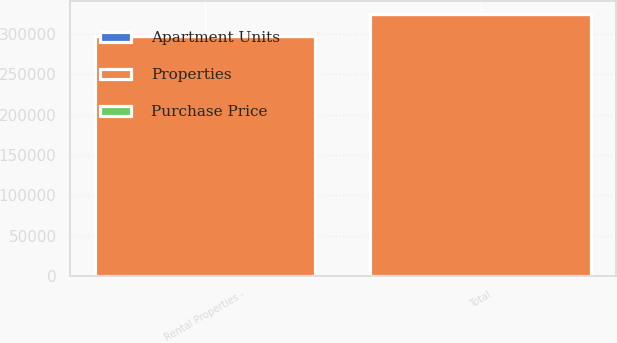<chart> <loc_0><loc_0><loc_500><loc_500><stacked_bar_chart><ecel><fcel>Rental Properties -<fcel>Total<nl><fcel>Purchase Price<fcel>4<fcel>4<nl><fcel>Apartment Units<fcel>625<fcel>625<nl><fcel>Properties<fcel>296037<fcel>323837<nl></chart> 